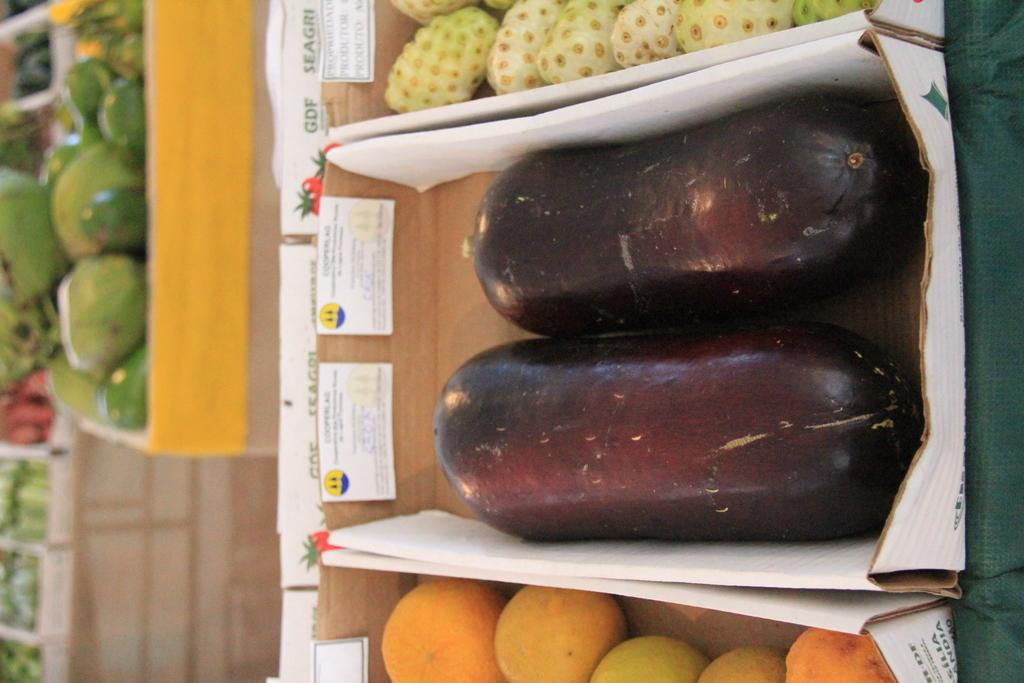What objects are present in the image? There are boxes in the image. What is inside the boxes? The boxes contain different kinds of fruits. What type of wind can be seen blowing through the boxes in the image? There is no wind present in the image; it is a still image of boxes containing fruits. Are there any marbles visible in the image? There are no marbles present in the image; it only contains boxes with fruits. 